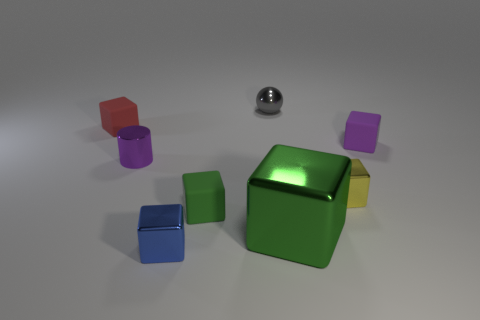Is the number of small green matte objects in front of the big shiny object less than the number of red blocks in front of the tiny purple block?
Ensure brevity in your answer.  No. Are there any small brown rubber objects of the same shape as the green metallic object?
Your answer should be very brief. No. Do the purple metallic thing and the tiny yellow thing have the same shape?
Your answer should be very brief. No. How many big things are either brown matte spheres or gray spheres?
Offer a very short reply. 0. Is the number of red spheres greater than the number of tiny rubber objects?
Your answer should be very brief. No. There is a gray ball that is made of the same material as the tiny blue cube; what size is it?
Your answer should be compact. Small. Is the size of the shiny object behind the red rubber thing the same as the green cube in front of the tiny green cube?
Your answer should be compact. No. How many things are tiny purple objects to the left of the tiny yellow block or big green metallic objects?
Your answer should be compact. 2. Is the number of large green metal balls less than the number of yellow blocks?
Keep it short and to the point. Yes. What is the shape of the metal object that is behind the shiny cylinder that is to the left of the small thing on the right side of the yellow shiny block?
Your answer should be very brief. Sphere. 